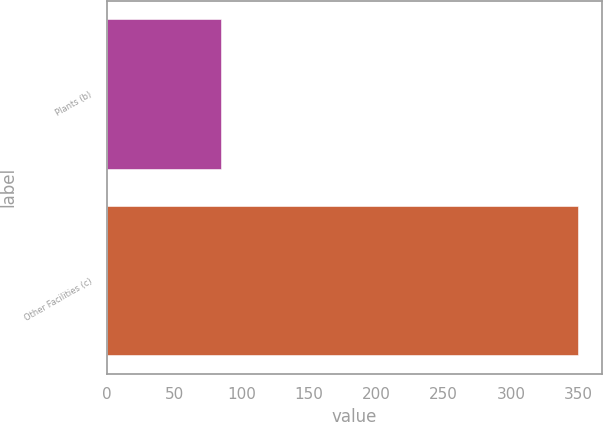Convert chart to OTSL. <chart><loc_0><loc_0><loc_500><loc_500><bar_chart><fcel>Plants (b)<fcel>Other Facilities (c)<nl><fcel>85<fcel>350<nl></chart> 